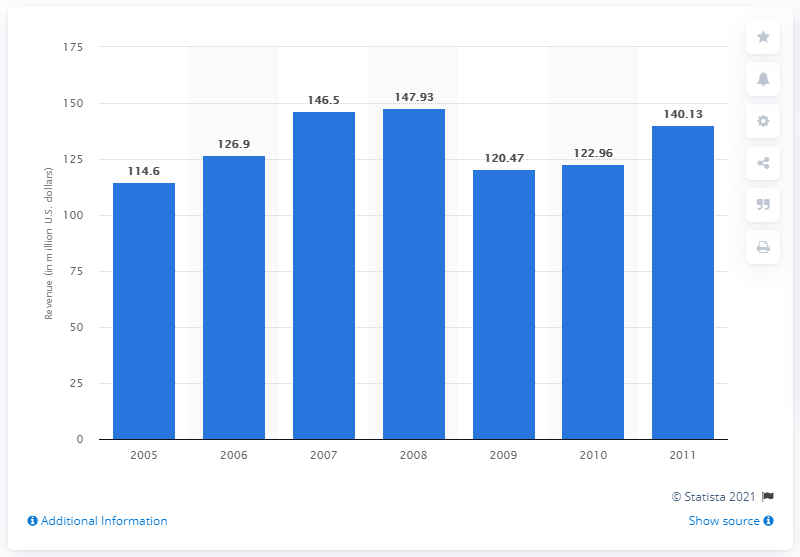Mention a couple of crucial points in this snapshot. In 2006, the revenue of Cybex was 126.9 million dollars. 